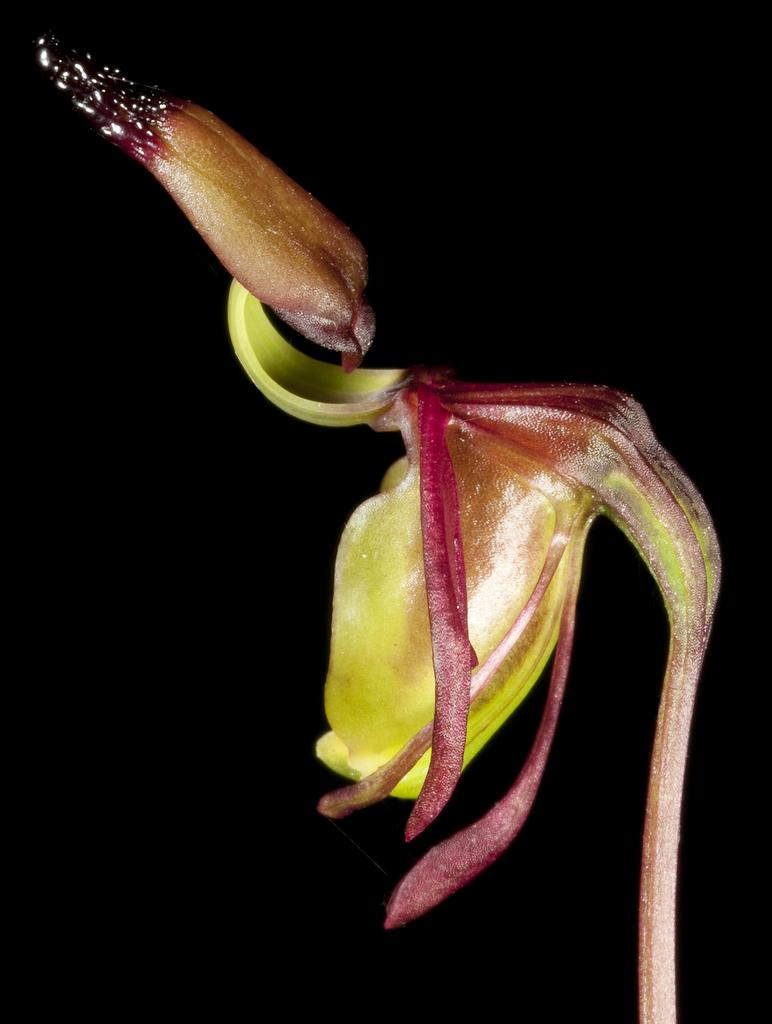What is the main subject in the center of the image? There is a flower in the center of the image. What is the flower's interest in the image? The flower does not have an interest, as it is an inanimate object. 